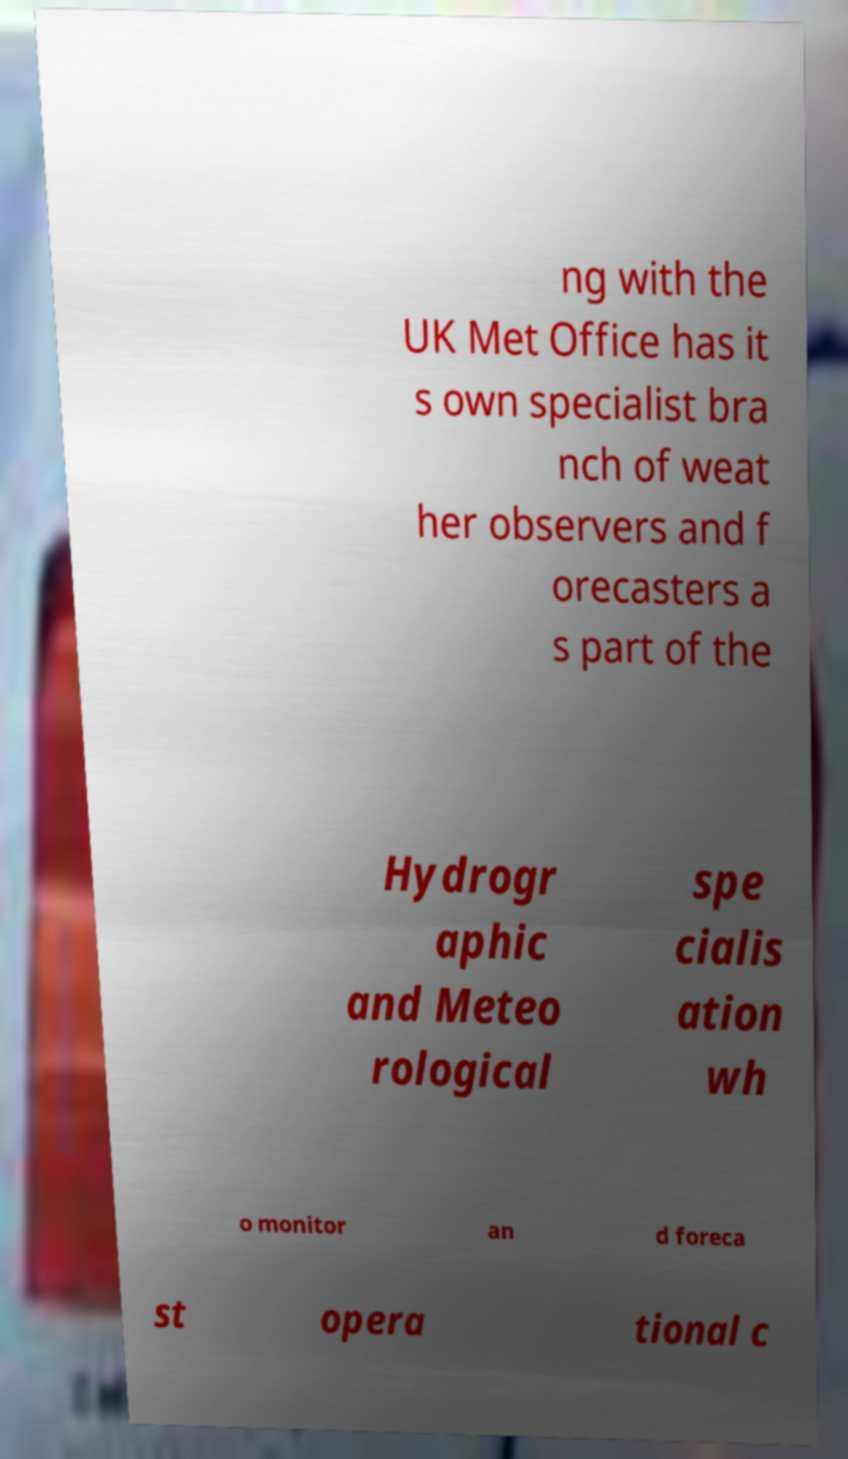Could you assist in decoding the text presented in this image and type it out clearly? ng with the UK Met Office has it s own specialist bra nch of weat her observers and f orecasters a s part of the Hydrogr aphic and Meteo rological spe cialis ation wh o monitor an d foreca st opera tional c 